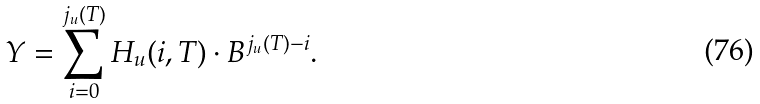Convert formula to latex. <formula><loc_0><loc_0><loc_500><loc_500>Y = \sum _ { i = 0 } ^ { j _ { u } ( T ) } H _ { u } ( i , T ) \cdot B ^ { j _ { u } ( T ) - i } .</formula> 